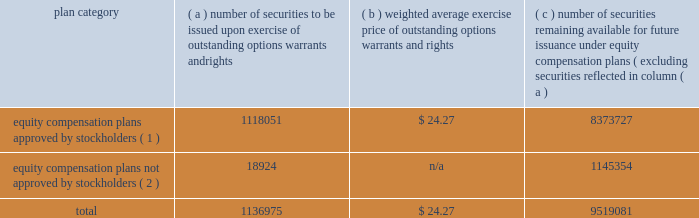Dividends and distributions we pay regular quarterly dividends to holders of our common stock .
On february 16 , 2007 , our board of directors declared the first quarterly installment of our 2007 dividend in the amount of $ 0.475 per share , payable on march 30 , 2007 to stockholders of record on march 20 , 2007 .
We expect to distribute 100% ( 100 % ) or more of our taxable net income to our stockholders for 2007 .
Our board of directors normally makes decisions regarding the frequency and amount of our dividends on a quarterly basis .
Because the board considers a number of factors when making these decisions , we cannot assure you that we will maintain the policy stated above .
Please see 201ccautionary statements 201d and the risk factors included in part i , item 1a of this annual report on form 10-k for a description of other factors that may affect our distribution policy .
Our stockholders may reinvest all or a portion of any cash distribution on their shares of our common stock by participating in our distribution reinvestment and stock purchase plan , subject to the terms of the plan .
See 201cnote 15 2014capital stock 201d of the notes to consolidated financial statements included in item 8 of this annual report on form 10-k .
Director and employee stock sales certain of our directors , executive officers and other employees have adopted and may , from time to time in the future , adopt non-discretionary , written trading plans that comply with rule 10b5-1 under the exchange act , or otherwise monetize their equity-based compensation .
Securities authorized for issuance under equity compensation plans the table summarizes information with respect to our equity compensation plans as of december 31 , 2006 : plan category number of securities to be issued upon exercise of outstanding options , warrants and rights weighted average exercise price of outstanding options , warrants and rights number of securities remaining available for future issuance under equity compensation plans ( excluding securities reflected in column ( a ) equity compensation plans approved by stockholders ( 1 ) .
1118051 $ 24.27 8373727 equity compensation plans not approved by stockholders ( 2 ) .
18924 n/a 1145354 .
( 1 ) these plans consist of ( i ) the 1987 incentive compensation program ( employee plan ) ; ( ii ) the theratx , incorporated 1996 stock option/stock issuance plan ; ( iii ) the 2000 incentive compensation plan ( employee plan ) ( formerly known as the 1997 incentive compensation plan ) ; ( iv ) the 2004 stock plan for directors ( which amended and restated the 2000 stock option plan for directors ( formerly known as the 1997 stock option plan for non-employee directors ) ) ; ( v ) the employee and director stock purchase plan ; ( vi ) the 2006 incentive plan ; and ( vii ) the 2006 stock plan for directors .
( 2 ) these plans consist of ( i ) the common stock purchase plan for directors , under which our non-employee directors may receive common stock in lieu of directors 2019 fees , ( ii ) the nonemployee director deferred stock compensation plan , under which our non-employee directors may receive units convertible on a one-for-one basis into common stock in lieu of director fees , and ( iii ) the executive deferred stock compensation plan , under which our executive officers may receive units convertible on a one-for-one basis into common stock in lieu of compensation. .
What is the percentage of number of securities to be issued upon exercise of outstanding options warrants and rights compared to number of securities remaining available for future issuance under equity compensation plans? 
Computations: (1136975 / 9519081)
Answer: 0.11944. 